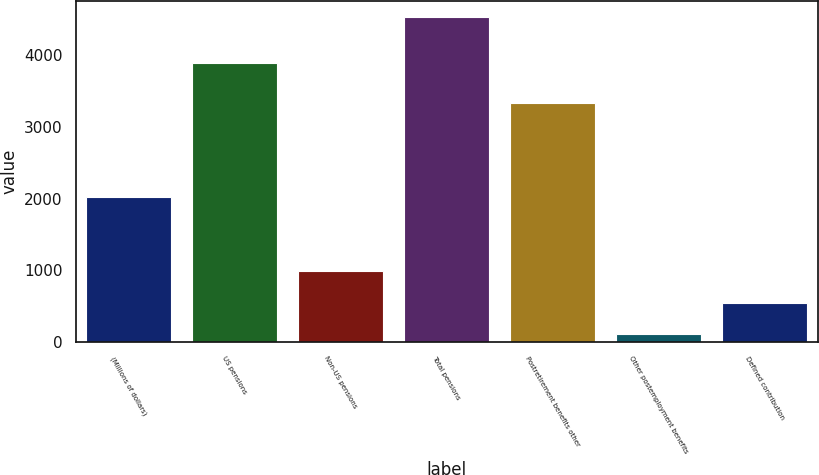Convert chart to OTSL. <chart><loc_0><loc_0><loc_500><loc_500><bar_chart><fcel>(Millions of dollars)<fcel>US pensions<fcel>Non-US pensions<fcel>Total pensions<fcel>Postretirement benefits other<fcel>Other postemployment benefits<fcel>Defined contribution<nl><fcel>2017<fcel>3891<fcel>993.2<fcel>4530<fcel>3335<fcel>109<fcel>551.1<nl></chart> 